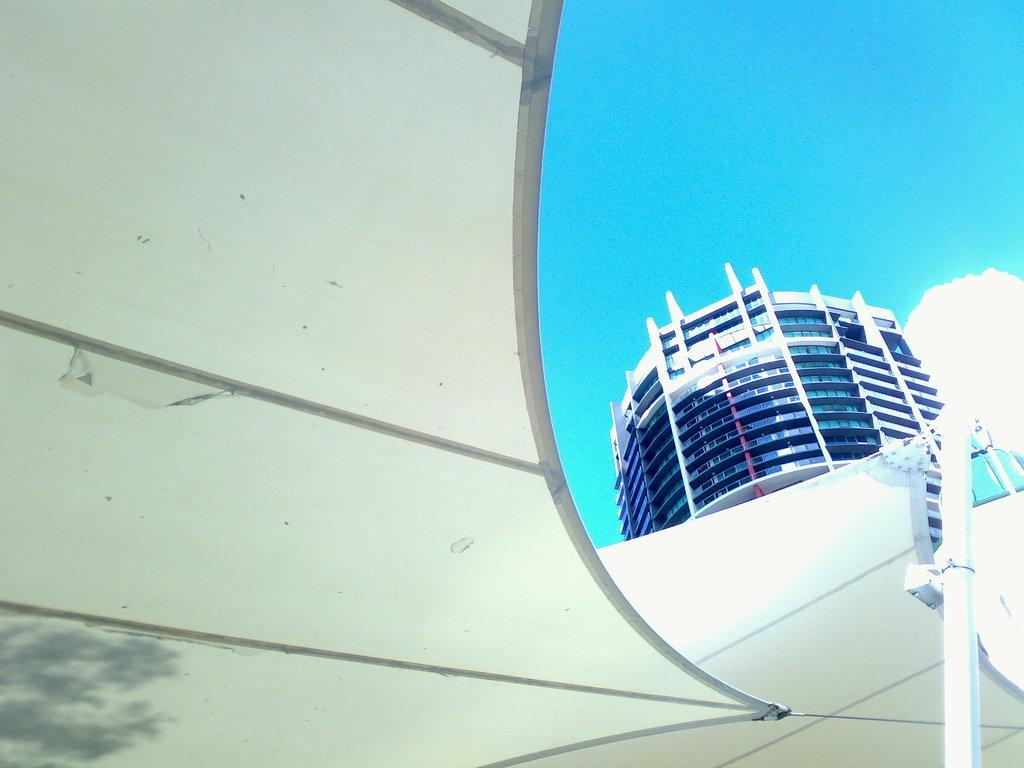What type of structure can be seen in the foreground of the image? There is a shed in the image. What other buildings can be seen in the image? There is a building with multiple floors visible behind the shed. What can be seen in the background of the image? The sky is visible in the background of the image. How many beetles can be seen crawling on the shed in the image? There are no beetles visible in the image; it only features a shed and a building with multiple floors. What type of grip does the sky have on the shed in the image? The sky does not have a grip on the shed; it is simply the background of the image. 